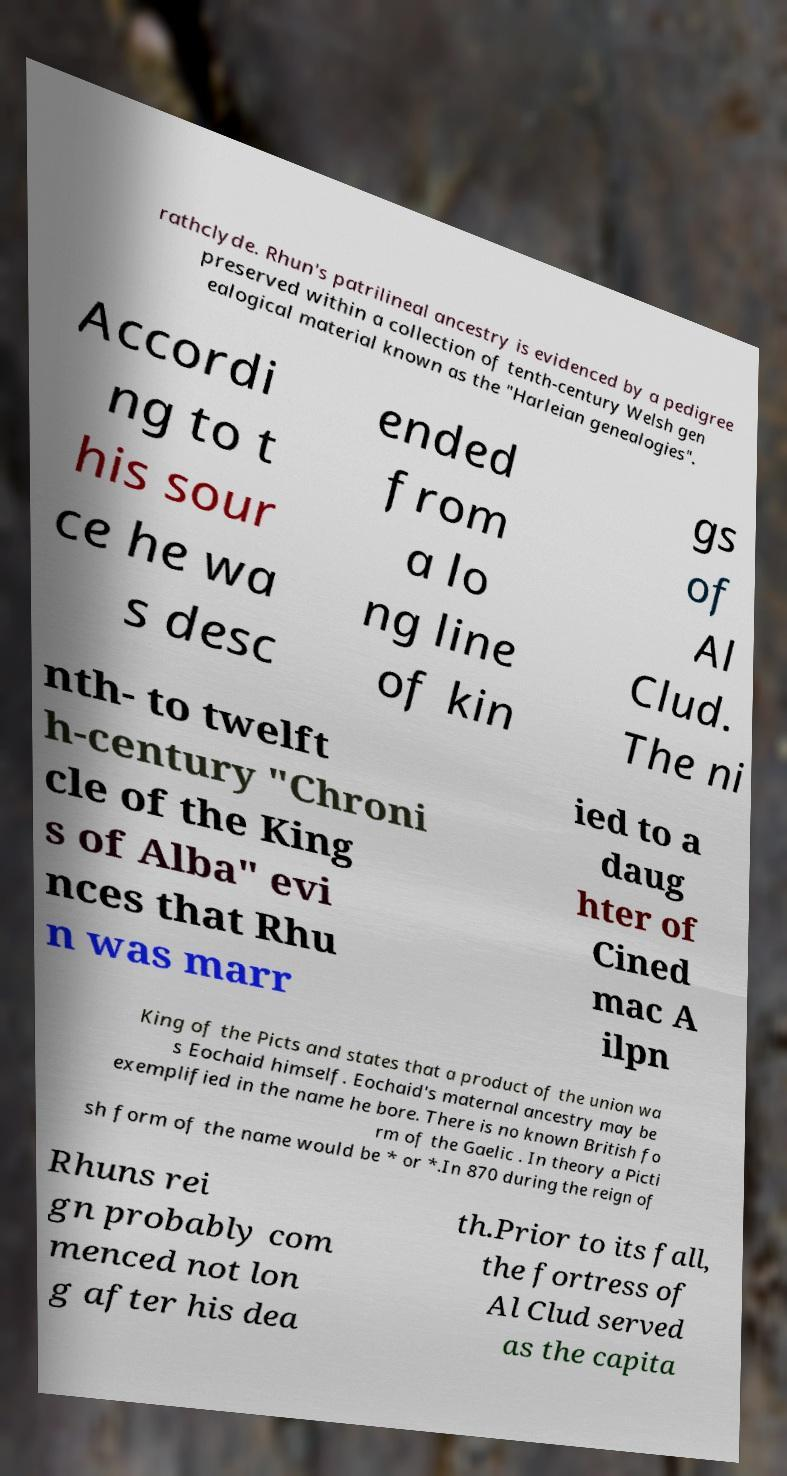For documentation purposes, I need the text within this image transcribed. Could you provide that? rathclyde. Rhun's patrilineal ancestry is evidenced by a pedigree preserved within a collection of tenth-century Welsh gen ealogical material known as the "Harleian genealogies". Accordi ng to t his sour ce he wa s desc ended from a lo ng line of kin gs of Al Clud. The ni nth- to twelft h-century "Chroni cle of the King s of Alba" evi nces that Rhu n was marr ied to a daug hter of Cined mac A ilpn King of the Picts and states that a product of the union wa s Eochaid himself. Eochaid's maternal ancestry may be exemplified in the name he bore. There is no known British fo rm of the Gaelic . In theory a Picti sh form of the name would be * or *.In 870 during the reign of Rhuns rei gn probably com menced not lon g after his dea th.Prior to its fall, the fortress of Al Clud served as the capita 